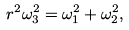<formula> <loc_0><loc_0><loc_500><loc_500>r ^ { 2 } \omega _ { 3 } ^ { 2 } & = \omega _ { 1 } ^ { 2 } + \omega _ { 2 } ^ { 2 } ,</formula> 